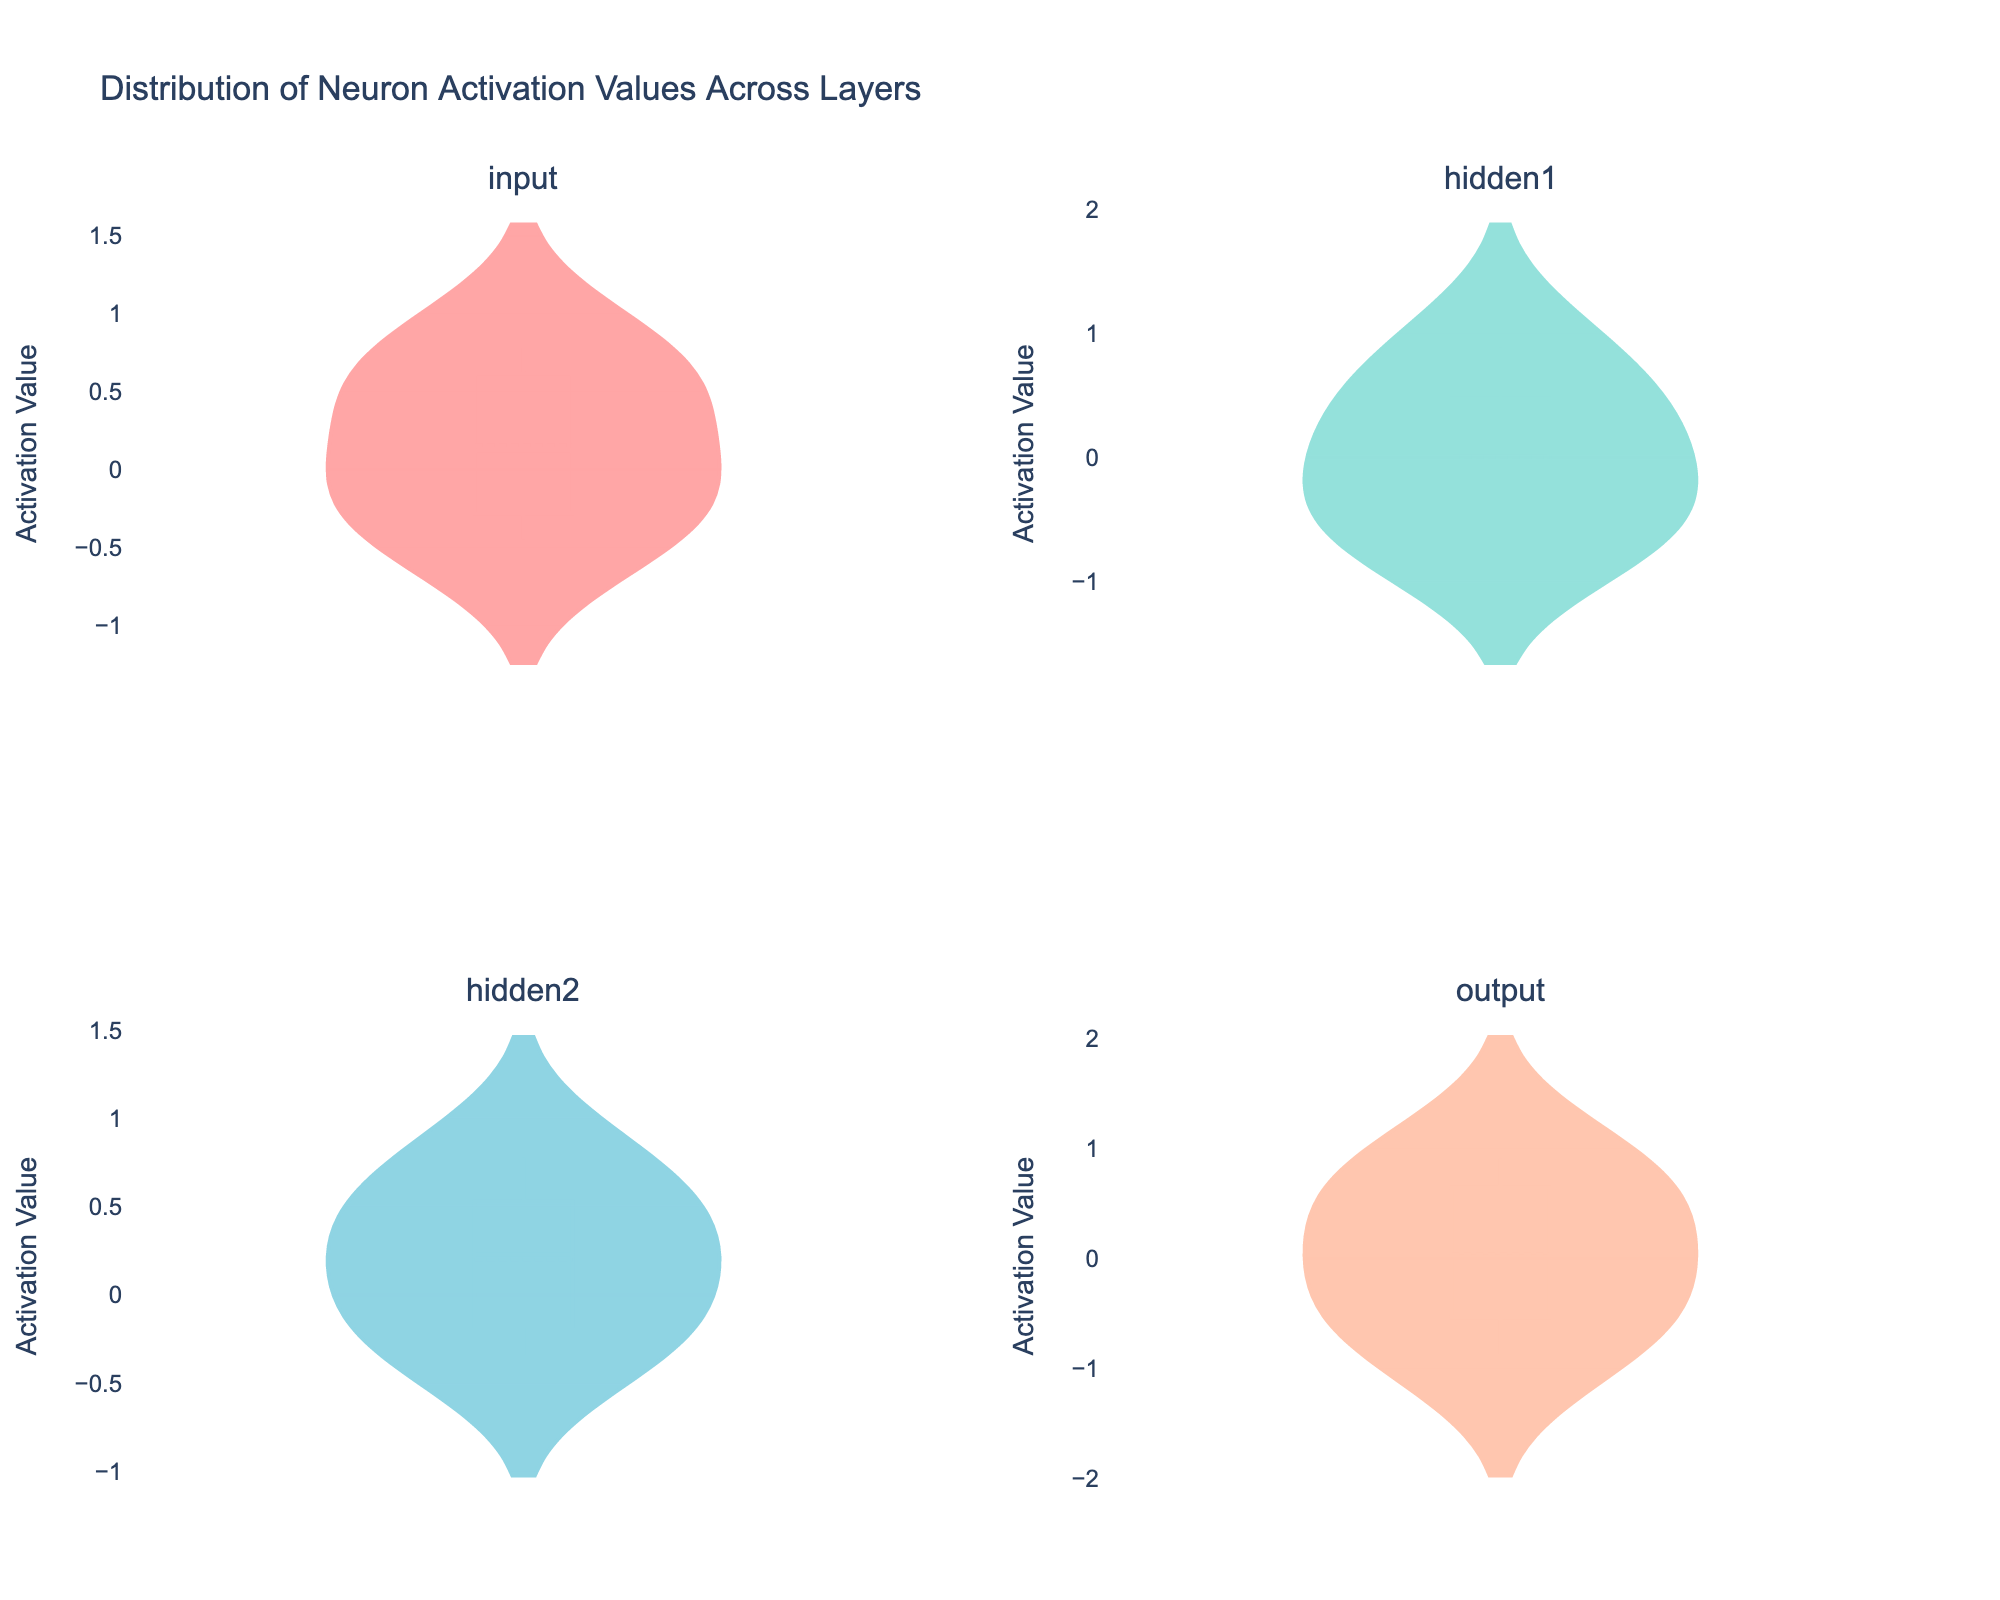What is the title of the figure? The title is usually found at the top of the figure and reflects the main subject of the plot. In this case, the title should signify the data being visualized.
Answer: Distribution of Neuron Activation Values Across Layers Which layer's distribution appears to have the widest spread of activation values? By looking at the width of the violin plots, we can see the range of activation values. The layer with the widest distribution will have a broader violin shape.
Answer: hidden1 What is the color assigned to the violin plot for the 'input' layer? The color of the violin plot can be identified by observing the visual representation of the 'input' distribution in the figure.
Answer: #FF6B6B (red) Among the 'input' and 'output' layers, which has a higher mean activation value? The mean activation value can be found by identifying the horizontal line within each violin plot for 'input' and 'output'. Compare these means visually.
Answer: output How many layers are shown in the figure? The total number of subplots in the figure corresponds to the number of different neural network layers represented. Count them to find the answer.
Answer: 4 Which layer has the lowest activation value and what is that value? By examining the minimum point of each violin plot, we can identify the lowest activation value visually.
Answer: output, -0.87 Which layer displays the highest concentration of values near zero? The concentration of values near zero can be observed by looking at the density of the central part of each violin plot. The layer with the densest central area has the highest concentration near zero.
Answer: hidden2 What is the approximate maximum activation value for the 'hidden1' layer? By identifying the topmost point of the violin plot for 'hidden1', we can determine the maximum activation value visually.
Answer: 0.89 How does the distribution of activation values in 'hidden2' compare to 'input'? The shape and spread of the violin plots indicate the distribution. A narrower plot implies a tighter distribution, while a wider one indicates more spread. Compare these characteristics for 'hidden2' and 'input'.
Answer: hidden2 is narrower and more centered around zero compared to the wider and more spread-out 'input' 